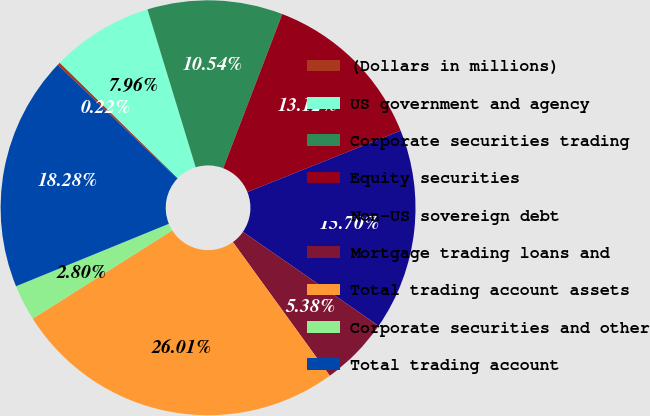Convert chart to OTSL. <chart><loc_0><loc_0><loc_500><loc_500><pie_chart><fcel>(Dollars in millions)<fcel>US government and agency<fcel>Corporate securities trading<fcel>Equity securities<fcel>Non-US sovereign debt<fcel>Mortgage trading loans and<fcel>Total trading account assets<fcel>Corporate securities and other<fcel>Total trading account<nl><fcel>0.22%<fcel>7.96%<fcel>10.54%<fcel>13.12%<fcel>15.7%<fcel>5.38%<fcel>26.01%<fcel>2.8%<fcel>18.28%<nl></chart> 